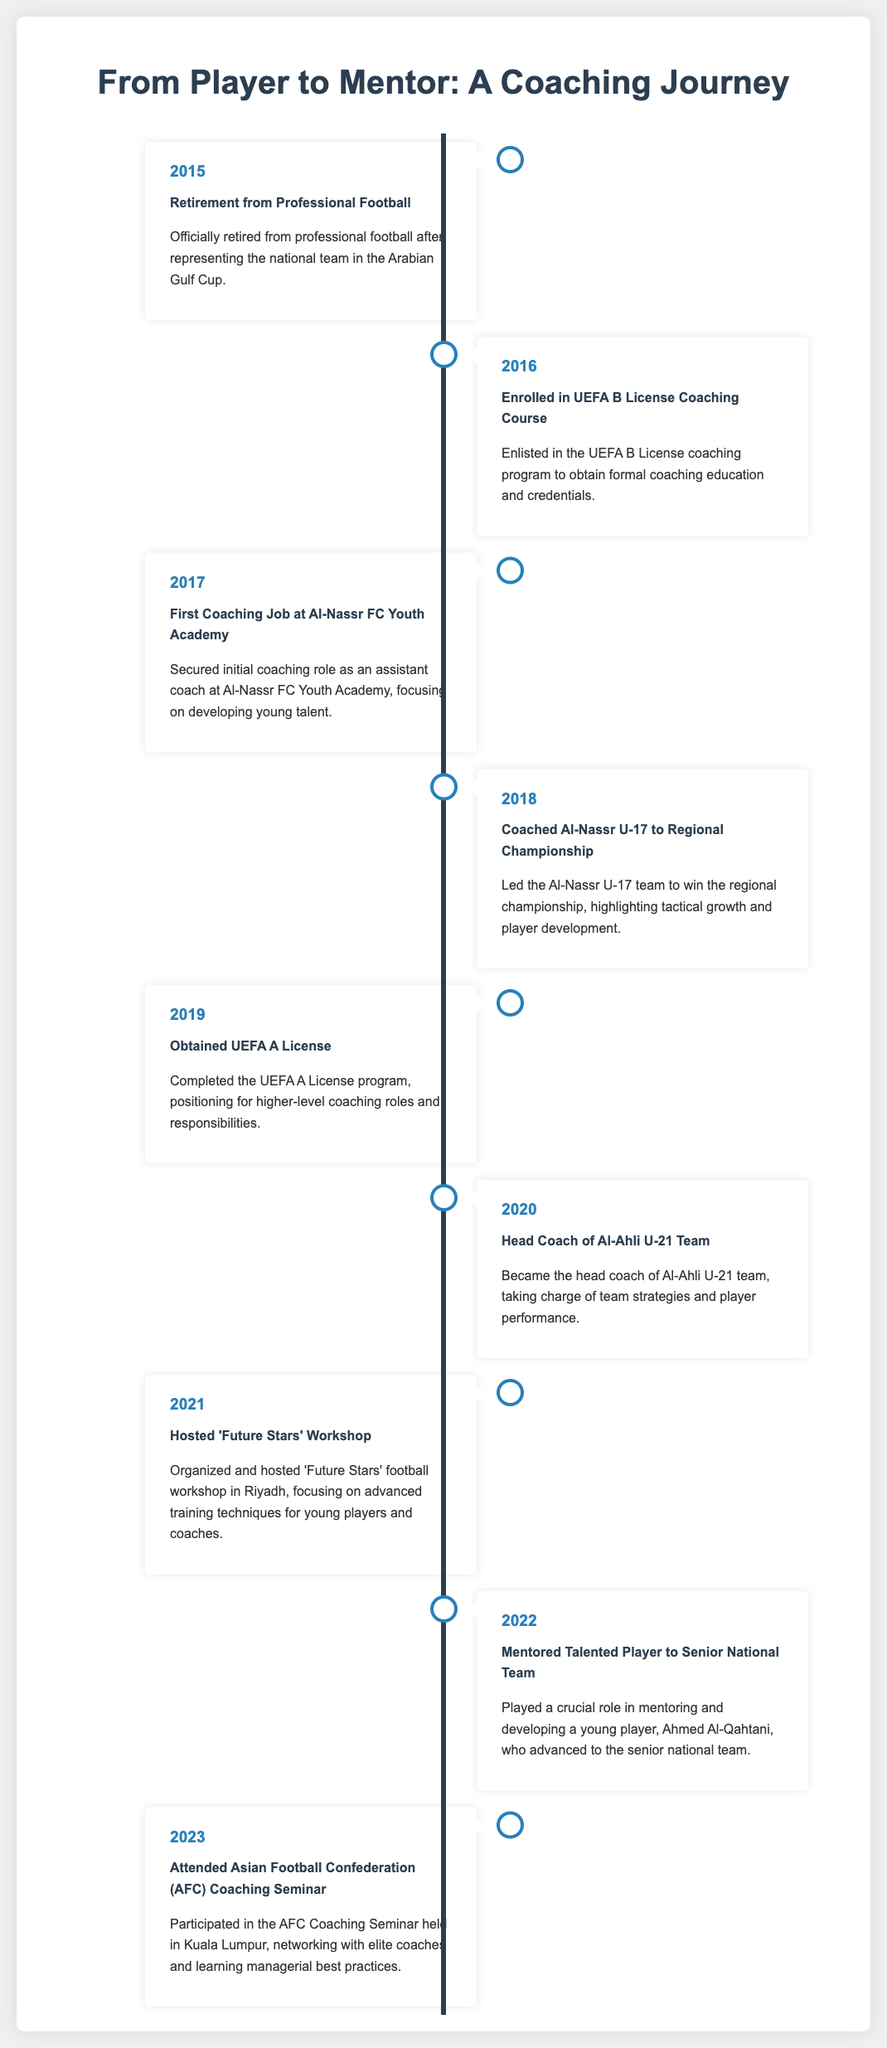What year did you retire from professional football? The document states the retirement year clearly as 2015.
Answer: 2015 What coaching course did you enroll in first? It mentions that the UEFA B License coaching course was the first course you enrolled in.
Answer: UEFA B License Which team did you first coach? The document specifies the first coaching job was at Al-Nassr FC Youth Academy.
Answer: Al-Nassr FC Youth Academy How many notable achievements of mentored players are highlighted? The timeline highlights one notable achievement of a mentored player who joined the senior national team.
Answer: One What year did you obtain the UEFA A License? The document lists the year you obtained the UEFA A License as 2019.
Answer: 2019 What significant workshop did you host in 2021? The document explicitly states that you hosted the 'Future Stars' workshop.
Answer: 'Future Stars' What was the primary focus of the 'Future Stars' workshop? It is indicated that the workshop focused on advanced training techniques for young players and coaches.
Answer: Advanced training techniques In which year did you become the head coach of Al-Ahli U-21 Team? The timeline clearly mentions that you became the head coach in 2020.
Answer: 2020 Where was the AFC Coaching Seminar held? The document specifies that the seminar was held in Kuala Lumpur.
Answer: Kuala Lumpur 